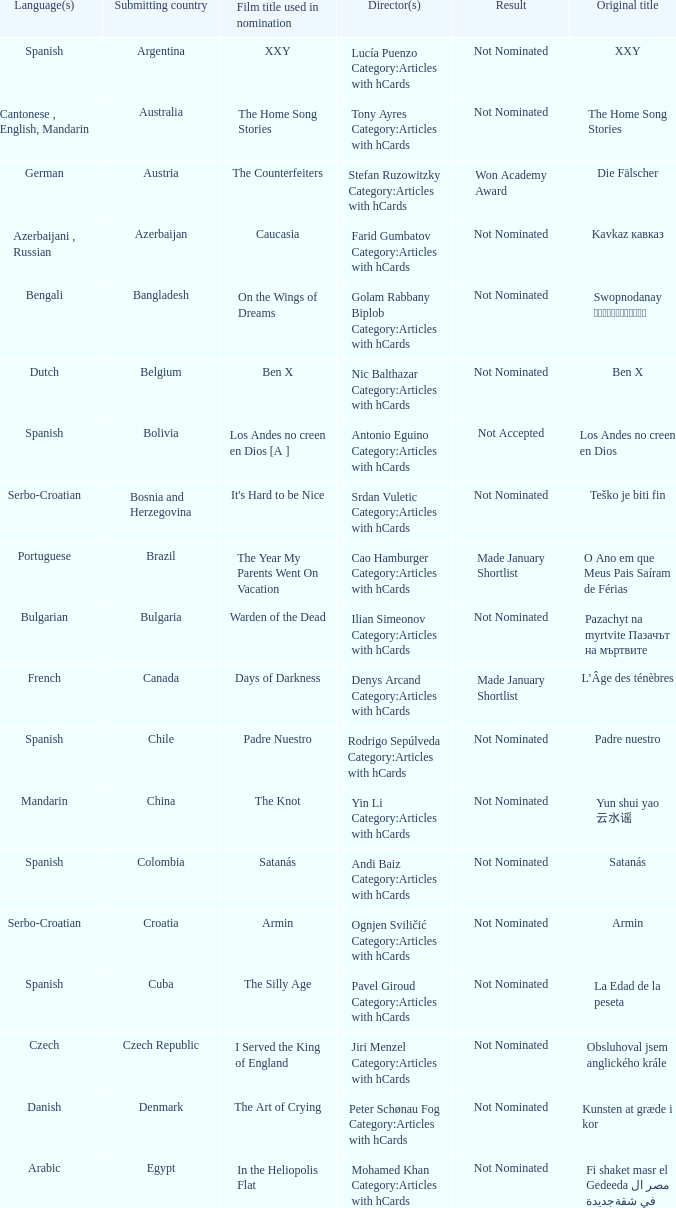What country submitted miehen työ? Finland. 